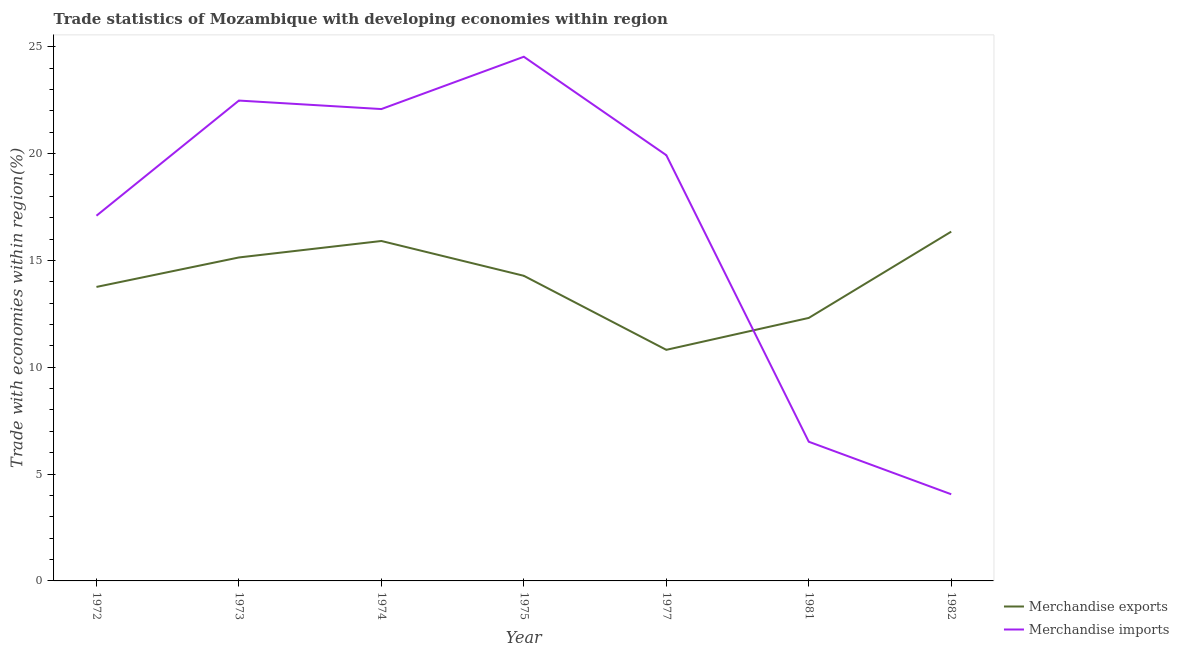What is the merchandise imports in 1972?
Offer a terse response. 17.09. Across all years, what is the maximum merchandise imports?
Offer a terse response. 24.53. Across all years, what is the minimum merchandise exports?
Give a very brief answer. 10.81. In which year was the merchandise exports maximum?
Keep it short and to the point. 1982. In which year was the merchandise imports minimum?
Provide a succinct answer. 1982. What is the total merchandise exports in the graph?
Your response must be concise. 98.55. What is the difference between the merchandise exports in 1973 and that in 1981?
Your answer should be very brief. 2.83. What is the difference between the merchandise imports in 1973 and the merchandise exports in 1981?
Provide a short and direct response. 10.17. What is the average merchandise exports per year?
Provide a succinct answer. 14.08. In the year 1974, what is the difference between the merchandise imports and merchandise exports?
Your response must be concise. 6.17. What is the ratio of the merchandise exports in 1981 to that in 1982?
Make the answer very short. 0.75. Is the merchandise exports in 1975 less than that in 1981?
Your response must be concise. No. What is the difference between the highest and the second highest merchandise imports?
Make the answer very short. 2.05. What is the difference between the highest and the lowest merchandise imports?
Ensure brevity in your answer.  20.47. In how many years, is the merchandise imports greater than the average merchandise imports taken over all years?
Keep it short and to the point. 5. Does the merchandise imports monotonically increase over the years?
Your answer should be compact. No. Is the merchandise exports strictly greater than the merchandise imports over the years?
Your answer should be compact. No. How many lines are there?
Provide a succinct answer. 2. Where does the legend appear in the graph?
Make the answer very short. Bottom right. How many legend labels are there?
Provide a short and direct response. 2. What is the title of the graph?
Keep it short and to the point. Trade statistics of Mozambique with developing economies within region. What is the label or title of the Y-axis?
Keep it short and to the point. Trade with economies within region(%). What is the Trade with economies within region(%) of Merchandise exports in 1972?
Your answer should be very brief. 13.76. What is the Trade with economies within region(%) of Merchandise imports in 1972?
Give a very brief answer. 17.09. What is the Trade with economies within region(%) in Merchandise exports in 1973?
Your answer should be very brief. 15.14. What is the Trade with economies within region(%) in Merchandise imports in 1973?
Keep it short and to the point. 22.48. What is the Trade with economies within region(%) in Merchandise exports in 1974?
Your response must be concise. 15.91. What is the Trade with economies within region(%) in Merchandise imports in 1974?
Your response must be concise. 22.08. What is the Trade with economies within region(%) of Merchandise exports in 1975?
Provide a succinct answer. 14.28. What is the Trade with economies within region(%) in Merchandise imports in 1975?
Make the answer very short. 24.53. What is the Trade with economies within region(%) in Merchandise exports in 1977?
Give a very brief answer. 10.81. What is the Trade with economies within region(%) of Merchandise imports in 1977?
Your response must be concise. 19.92. What is the Trade with economies within region(%) in Merchandise exports in 1981?
Your answer should be very brief. 12.31. What is the Trade with economies within region(%) in Merchandise imports in 1981?
Give a very brief answer. 6.51. What is the Trade with economies within region(%) of Merchandise exports in 1982?
Provide a short and direct response. 16.35. What is the Trade with economies within region(%) of Merchandise imports in 1982?
Offer a very short reply. 4.05. Across all years, what is the maximum Trade with economies within region(%) in Merchandise exports?
Offer a terse response. 16.35. Across all years, what is the maximum Trade with economies within region(%) of Merchandise imports?
Your answer should be compact. 24.53. Across all years, what is the minimum Trade with economies within region(%) in Merchandise exports?
Give a very brief answer. 10.81. Across all years, what is the minimum Trade with economies within region(%) of Merchandise imports?
Give a very brief answer. 4.05. What is the total Trade with economies within region(%) of Merchandise exports in the graph?
Provide a short and direct response. 98.55. What is the total Trade with economies within region(%) of Merchandise imports in the graph?
Make the answer very short. 116.67. What is the difference between the Trade with economies within region(%) in Merchandise exports in 1972 and that in 1973?
Provide a short and direct response. -1.38. What is the difference between the Trade with economies within region(%) of Merchandise imports in 1972 and that in 1973?
Your answer should be very brief. -5.39. What is the difference between the Trade with economies within region(%) of Merchandise exports in 1972 and that in 1974?
Provide a short and direct response. -2.15. What is the difference between the Trade with economies within region(%) in Merchandise imports in 1972 and that in 1974?
Your response must be concise. -4.99. What is the difference between the Trade with economies within region(%) of Merchandise exports in 1972 and that in 1975?
Ensure brevity in your answer.  -0.52. What is the difference between the Trade with economies within region(%) in Merchandise imports in 1972 and that in 1975?
Provide a succinct answer. -7.44. What is the difference between the Trade with economies within region(%) in Merchandise exports in 1972 and that in 1977?
Your response must be concise. 2.94. What is the difference between the Trade with economies within region(%) in Merchandise imports in 1972 and that in 1977?
Offer a very short reply. -2.83. What is the difference between the Trade with economies within region(%) in Merchandise exports in 1972 and that in 1981?
Your response must be concise. 1.45. What is the difference between the Trade with economies within region(%) of Merchandise imports in 1972 and that in 1981?
Ensure brevity in your answer.  10.58. What is the difference between the Trade with economies within region(%) in Merchandise exports in 1972 and that in 1982?
Keep it short and to the point. -2.59. What is the difference between the Trade with economies within region(%) of Merchandise imports in 1972 and that in 1982?
Provide a short and direct response. 13.04. What is the difference between the Trade with economies within region(%) in Merchandise exports in 1973 and that in 1974?
Provide a short and direct response. -0.77. What is the difference between the Trade with economies within region(%) in Merchandise imports in 1973 and that in 1974?
Your response must be concise. 0.4. What is the difference between the Trade with economies within region(%) in Merchandise exports in 1973 and that in 1975?
Provide a succinct answer. 0.86. What is the difference between the Trade with economies within region(%) of Merchandise imports in 1973 and that in 1975?
Your answer should be very brief. -2.05. What is the difference between the Trade with economies within region(%) of Merchandise exports in 1973 and that in 1977?
Your answer should be very brief. 4.32. What is the difference between the Trade with economies within region(%) of Merchandise imports in 1973 and that in 1977?
Offer a terse response. 2.56. What is the difference between the Trade with economies within region(%) of Merchandise exports in 1973 and that in 1981?
Ensure brevity in your answer.  2.83. What is the difference between the Trade with economies within region(%) in Merchandise imports in 1973 and that in 1981?
Keep it short and to the point. 15.97. What is the difference between the Trade with economies within region(%) in Merchandise exports in 1973 and that in 1982?
Keep it short and to the point. -1.21. What is the difference between the Trade with economies within region(%) of Merchandise imports in 1973 and that in 1982?
Your response must be concise. 18.42. What is the difference between the Trade with economies within region(%) of Merchandise exports in 1974 and that in 1975?
Offer a very short reply. 1.63. What is the difference between the Trade with economies within region(%) of Merchandise imports in 1974 and that in 1975?
Offer a very short reply. -2.45. What is the difference between the Trade with economies within region(%) in Merchandise exports in 1974 and that in 1977?
Keep it short and to the point. 5.09. What is the difference between the Trade with economies within region(%) of Merchandise imports in 1974 and that in 1977?
Offer a very short reply. 2.16. What is the difference between the Trade with economies within region(%) of Merchandise exports in 1974 and that in 1981?
Give a very brief answer. 3.6. What is the difference between the Trade with economies within region(%) of Merchandise imports in 1974 and that in 1981?
Keep it short and to the point. 15.57. What is the difference between the Trade with economies within region(%) in Merchandise exports in 1974 and that in 1982?
Offer a very short reply. -0.44. What is the difference between the Trade with economies within region(%) in Merchandise imports in 1974 and that in 1982?
Ensure brevity in your answer.  18.03. What is the difference between the Trade with economies within region(%) in Merchandise exports in 1975 and that in 1977?
Offer a terse response. 3.46. What is the difference between the Trade with economies within region(%) in Merchandise imports in 1975 and that in 1977?
Your answer should be very brief. 4.61. What is the difference between the Trade with economies within region(%) in Merchandise exports in 1975 and that in 1981?
Give a very brief answer. 1.97. What is the difference between the Trade with economies within region(%) in Merchandise imports in 1975 and that in 1981?
Make the answer very short. 18.02. What is the difference between the Trade with economies within region(%) of Merchandise exports in 1975 and that in 1982?
Provide a succinct answer. -2.07. What is the difference between the Trade with economies within region(%) in Merchandise imports in 1975 and that in 1982?
Ensure brevity in your answer.  20.47. What is the difference between the Trade with economies within region(%) of Merchandise exports in 1977 and that in 1981?
Keep it short and to the point. -1.49. What is the difference between the Trade with economies within region(%) of Merchandise imports in 1977 and that in 1981?
Offer a very short reply. 13.41. What is the difference between the Trade with economies within region(%) of Merchandise exports in 1977 and that in 1982?
Your response must be concise. -5.53. What is the difference between the Trade with economies within region(%) of Merchandise imports in 1977 and that in 1982?
Your response must be concise. 15.87. What is the difference between the Trade with economies within region(%) of Merchandise exports in 1981 and that in 1982?
Provide a succinct answer. -4.04. What is the difference between the Trade with economies within region(%) of Merchandise imports in 1981 and that in 1982?
Your answer should be very brief. 2.46. What is the difference between the Trade with economies within region(%) in Merchandise exports in 1972 and the Trade with economies within region(%) in Merchandise imports in 1973?
Offer a very short reply. -8.72. What is the difference between the Trade with economies within region(%) in Merchandise exports in 1972 and the Trade with economies within region(%) in Merchandise imports in 1974?
Offer a terse response. -8.32. What is the difference between the Trade with economies within region(%) of Merchandise exports in 1972 and the Trade with economies within region(%) of Merchandise imports in 1975?
Offer a very short reply. -10.77. What is the difference between the Trade with economies within region(%) of Merchandise exports in 1972 and the Trade with economies within region(%) of Merchandise imports in 1977?
Your answer should be compact. -6.17. What is the difference between the Trade with economies within region(%) of Merchandise exports in 1972 and the Trade with economies within region(%) of Merchandise imports in 1981?
Keep it short and to the point. 7.24. What is the difference between the Trade with economies within region(%) in Merchandise exports in 1972 and the Trade with economies within region(%) in Merchandise imports in 1982?
Keep it short and to the point. 9.7. What is the difference between the Trade with economies within region(%) in Merchandise exports in 1973 and the Trade with economies within region(%) in Merchandise imports in 1974?
Provide a succinct answer. -6.94. What is the difference between the Trade with economies within region(%) in Merchandise exports in 1973 and the Trade with economies within region(%) in Merchandise imports in 1975?
Your response must be concise. -9.39. What is the difference between the Trade with economies within region(%) of Merchandise exports in 1973 and the Trade with economies within region(%) of Merchandise imports in 1977?
Keep it short and to the point. -4.79. What is the difference between the Trade with economies within region(%) in Merchandise exports in 1973 and the Trade with economies within region(%) in Merchandise imports in 1981?
Provide a succinct answer. 8.62. What is the difference between the Trade with economies within region(%) in Merchandise exports in 1973 and the Trade with economies within region(%) in Merchandise imports in 1982?
Give a very brief answer. 11.08. What is the difference between the Trade with economies within region(%) of Merchandise exports in 1974 and the Trade with economies within region(%) of Merchandise imports in 1975?
Provide a short and direct response. -8.62. What is the difference between the Trade with economies within region(%) in Merchandise exports in 1974 and the Trade with economies within region(%) in Merchandise imports in 1977?
Ensure brevity in your answer.  -4.02. What is the difference between the Trade with economies within region(%) in Merchandise exports in 1974 and the Trade with economies within region(%) in Merchandise imports in 1981?
Ensure brevity in your answer.  9.39. What is the difference between the Trade with economies within region(%) in Merchandise exports in 1974 and the Trade with economies within region(%) in Merchandise imports in 1982?
Give a very brief answer. 11.85. What is the difference between the Trade with economies within region(%) in Merchandise exports in 1975 and the Trade with economies within region(%) in Merchandise imports in 1977?
Provide a succinct answer. -5.64. What is the difference between the Trade with economies within region(%) of Merchandise exports in 1975 and the Trade with economies within region(%) of Merchandise imports in 1981?
Ensure brevity in your answer.  7.77. What is the difference between the Trade with economies within region(%) in Merchandise exports in 1975 and the Trade with economies within region(%) in Merchandise imports in 1982?
Your answer should be very brief. 10.22. What is the difference between the Trade with economies within region(%) of Merchandise exports in 1977 and the Trade with economies within region(%) of Merchandise imports in 1981?
Keep it short and to the point. 4.3. What is the difference between the Trade with economies within region(%) of Merchandise exports in 1977 and the Trade with economies within region(%) of Merchandise imports in 1982?
Your response must be concise. 6.76. What is the difference between the Trade with economies within region(%) in Merchandise exports in 1981 and the Trade with economies within region(%) in Merchandise imports in 1982?
Your response must be concise. 8.25. What is the average Trade with economies within region(%) of Merchandise exports per year?
Keep it short and to the point. 14.08. What is the average Trade with economies within region(%) in Merchandise imports per year?
Provide a succinct answer. 16.67. In the year 1972, what is the difference between the Trade with economies within region(%) of Merchandise exports and Trade with economies within region(%) of Merchandise imports?
Offer a very short reply. -3.33. In the year 1973, what is the difference between the Trade with economies within region(%) of Merchandise exports and Trade with economies within region(%) of Merchandise imports?
Provide a succinct answer. -7.34. In the year 1974, what is the difference between the Trade with economies within region(%) in Merchandise exports and Trade with economies within region(%) in Merchandise imports?
Make the answer very short. -6.17. In the year 1975, what is the difference between the Trade with economies within region(%) in Merchandise exports and Trade with economies within region(%) in Merchandise imports?
Provide a succinct answer. -10.25. In the year 1977, what is the difference between the Trade with economies within region(%) of Merchandise exports and Trade with economies within region(%) of Merchandise imports?
Ensure brevity in your answer.  -9.11. In the year 1981, what is the difference between the Trade with economies within region(%) of Merchandise exports and Trade with economies within region(%) of Merchandise imports?
Keep it short and to the point. 5.79. In the year 1982, what is the difference between the Trade with economies within region(%) of Merchandise exports and Trade with economies within region(%) of Merchandise imports?
Your answer should be compact. 12.29. What is the ratio of the Trade with economies within region(%) in Merchandise exports in 1972 to that in 1973?
Provide a succinct answer. 0.91. What is the ratio of the Trade with economies within region(%) of Merchandise imports in 1972 to that in 1973?
Your response must be concise. 0.76. What is the ratio of the Trade with economies within region(%) in Merchandise exports in 1972 to that in 1974?
Provide a succinct answer. 0.86. What is the ratio of the Trade with economies within region(%) in Merchandise imports in 1972 to that in 1974?
Provide a succinct answer. 0.77. What is the ratio of the Trade with economies within region(%) in Merchandise exports in 1972 to that in 1975?
Provide a short and direct response. 0.96. What is the ratio of the Trade with economies within region(%) of Merchandise imports in 1972 to that in 1975?
Offer a very short reply. 0.7. What is the ratio of the Trade with economies within region(%) of Merchandise exports in 1972 to that in 1977?
Your response must be concise. 1.27. What is the ratio of the Trade with economies within region(%) of Merchandise imports in 1972 to that in 1977?
Ensure brevity in your answer.  0.86. What is the ratio of the Trade with economies within region(%) of Merchandise exports in 1972 to that in 1981?
Your answer should be compact. 1.12. What is the ratio of the Trade with economies within region(%) in Merchandise imports in 1972 to that in 1981?
Provide a short and direct response. 2.62. What is the ratio of the Trade with economies within region(%) of Merchandise exports in 1972 to that in 1982?
Your answer should be very brief. 0.84. What is the ratio of the Trade with economies within region(%) of Merchandise imports in 1972 to that in 1982?
Your answer should be very brief. 4.21. What is the ratio of the Trade with economies within region(%) in Merchandise exports in 1973 to that in 1974?
Your answer should be compact. 0.95. What is the ratio of the Trade with economies within region(%) in Merchandise exports in 1973 to that in 1975?
Offer a terse response. 1.06. What is the ratio of the Trade with economies within region(%) in Merchandise imports in 1973 to that in 1975?
Provide a short and direct response. 0.92. What is the ratio of the Trade with economies within region(%) in Merchandise exports in 1973 to that in 1977?
Keep it short and to the point. 1.4. What is the ratio of the Trade with economies within region(%) in Merchandise imports in 1973 to that in 1977?
Your answer should be very brief. 1.13. What is the ratio of the Trade with economies within region(%) of Merchandise exports in 1973 to that in 1981?
Make the answer very short. 1.23. What is the ratio of the Trade with economies within region(%) in Merchandise imports in 1973 to that in 1981?
Make the answer very short. 3.45. What is the ratio of the Trade with economies within region(%) in Merchandise exports in 1973 to that in 1982?
Provide a short and direct response. 0.93. What is the ratio of the Trade with economies within region(%) in Merchandise imports in 1973 to that in 1982?
Provide a succinct answer. 5.54. What is the ratio of the Trade with economies within region(%) in Merchandise exports in 1974 to that in 1975?
Your answer should be very brief. 1.11. What is the ratio of the Trade with economies within region(%) of Merchandise imports in 1974 to that in 1975?
Your response must be concise. 0.9. What is the ratio of the Trade with economies within region(%) of Merchandise exports in 1974 to that in 1977?
Keep it short and to the point. 1.47. What is the ratio of the Trade with economies within region(%) of Merchandise imports in 1974 to that in 1977?
Make the answer very short. 1.11. What is the ratio of the Trade with economies within region(%) of Merchandise exports in 1974 to that in 1981?
Your answer should be compact. 1.29. What is the ratio of the Trade with economies within region(%) of Merchandise imports in 1974 to that in 1981?
Your answer should be compact. 3.39. What is the ratio of the Trade with economies within region(%) in Merchandise exports in 1974 to that in 1982?
Your answer should be very brief. 0.97. What is the ratio of the Trade with economies within region(%) in Merchandise imports in 1974 to that in 1982?
Give a very brief answer. 5.45. What is the ratio of the Trade with economies within region(%) of Merchandise exports in 1975 to that in 1977?
Provide a succinct answer. 1.32. What is the ratio of the Trade with economies within region(%) in Merchandise imports in 1975 to that in 1977?
Your answer should be compact. 1.23. What is the ratio of the Trade with economies within region(%) in Merchandise exports in 1975 to that in 1981?
Your answer should be very brief. 1.16. What is the ratio of the Trade with economies within region(%) in Merchandise imports in 1975 to that in 1981?
Your answer should be very brief. 3.77. What is the ratio of the Trade with economies within region(%) of Merchandise exports in 1975 to that in 1982?
Keep it short and to the point. 0.87. What is the ratio of the Trade with economies within region(%) of Merchandise imports in 1975 to that in 1982?
Offer a terse response. 6.05. What is the ratio of the Trade with economies within region(%) of Merchandise exports in 1977 to that in 1981?
Your response must be concise. 0.88. What is the ratio of the Trade with economies within region(%) in Merchandise imports in 1977 to that in 1981?
Your answer should be compact. 3.06. What is the ratio of the Trade with economies within region(%) in Merchandise exports in 1977 to that in 1982?
Provide a short and direct response. 0.66. What is the ratio of the Trade with economies within region(%) in Merchandise imports in 1977 to that in 1982?
Keep it short and to the point. 4.91. What is the ratio of the Trade with economies within region(%) of Merchandise exports in 1981 to that in 1982?
Provide a short and direct response. 0.75. What is the ratio of the Trade with economies within region(%) of Merchandise imports in 1981 to that in 1982?
Provide a succinct answer. 1.61. What is the difference between the highest and the second highest Trade with economies within region(%) of Merchandise exports?
Make the answer very short. 0.44. What is the difference between the highest and the second highest Trade with economies within region(%) of Merchandise imports?
Make the answer very short. 2.05. What is the difference between the highest and the lowest Trade with economies within region(%) of Merchandise exports?
Provide a short and direct response. 5.53. What is the difference between the highest and the lowest Trade with economies within region(%) in Merchandise imports?
Keep it short and to the point. 20.47. 